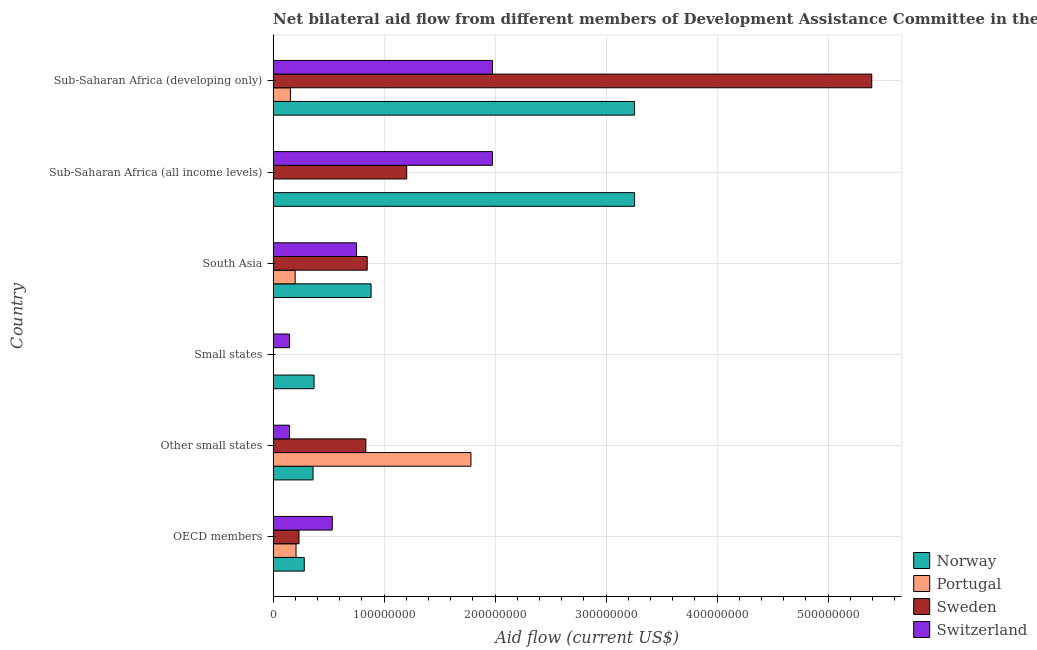How many groups of bars are there?
Your response must be concise. 6. Are the number of bars per tick equal to the number of legend labels?
Your answer should be very brief. Yes. How many bars are there on the 2nd tick from the bottom?
Offer a terse response. 4. What is the label of the 1st group of bars from the top?
Provide a succinct answer. Sub-Saharan Africa (developing only). What is the amount of aid given by portugal in South Asia?
Offer a terse response. 1.98e+07. Across all countries, what is the maximum amount of aid given by switzerland?
Make the answer very short. 1.98e+08. Across all countries, what is the minimum amount of aid given by portugal?
Make the answer very short. 4.00e+04. In which country was the amount of aid given by portugal maximum?
Offer a terse response. Other small states. In which country was the amount of aid given by norway minimum?
Your response must be concise. OECD members. What is the total amount of aid given by switzerland in the graph?
Provide a short and direct response. 5.53e+08. What is the difference between the amount of aid given by portugal in Small states and that in Sub-Saharan Africa (developing only)?
Your answer should be compact. -1.55e+07. What is the difference between the amount of aid given by portugal in South Asia and the amount of aid given by norway in OECD members?
Keep it short and to the point. -8.21e+06. What is the average amount of aid given by portugal per country?
Your answer should be very brief. 3.91e+07. What is the difference between the amount of aid given by norway and amount of aid given by switzerland in Sub-Saharan Africa (developing only)?
Offer a very short reply. 1.28e+08. In how many countries, is the amount of aid given by switzerland greater than 440000000 US$?
Keep it short and to the point. 0. What is the ratio of the amount of aid given by sweden in South Asia to that in Sub-Saharan Africa (all income levels)?
Your response must be concise. 0.7. Is the amount of aid given by sweden in OECD members less than that in Sub-Saharan Africa (all income levels)?
Give a very brief answer. Yes. Is the difference between the amount of aid given by sweden in Small states and South Asia greater than the difference between the amount of aid given by norway in Small states and South Asia?
Your answer should be compact. No. What is the difference between the highest and the second highest amount of aid given by sweden?
Ensure brevity in your answer.  4.19e+08. What is the difference between the highest and the lowest amount of aid given by sweden?
Ensure brevity in your answer.  5.39e+08. Is it the case that in every country, the sum of the amount of aid given by portugal and amount of aid given by switzerland is greater than the sum of amount of aid given by norway and amount of aid given by sweden?
Make the answer very short. No. How many bars are there?
Keep it short and to the point. 24. How many countries are there in the graph?
Provide a short and direct response. 6. What is the difference between two consecutive major ticks on the X-axis?
Offer a very short reply. 1.00e+08. Does the graph contain any zero values?
Ensure brevity in your answer.  No. How many legend labels are there?
Offer a terse response. 4. How are the legend labels stacked?
Make the answer very short. Vertical. What is the title of the graph?
Offer a very short reply. Net bilateral aid flow from different members of Development Assistance Committee in the year 1993. What is the label or title of the Y-axis?
Give a very brief answer. Country. What is the Aid flow (current US$) in Norway in OECD members?
Offer a terse response. 2.80e+07. What is the Aid flow (current US$) of Portugal in OECD members?
Keep it short and to the point. 2.06e+07. What is the Aid flow (current US$) of Sweden in OECD members?
Offer a very short reply. 2.33e+07. What is the Aid flow (current US$) in Switzerland in OECD members?
Offer a terse response. 5.33e+07. What is the Aid flow (current US$) in Norway in Other small states?
Provide a succinct answer. 3.60e+07. What is the Aid flow (current US$) of Portugal in Other small states?
Keep it short and to the point. 1.78e+08. What is the Aid flow (current US$) of Sweden in Other small states?
Ensure brevity in your answer.  8.35e+07. What is the Aid flow (current US$) of Switzerland in Other small states?
Your response must be concise. 1.48e+07. What is the Aid flow (current US$) in Norway in Small states?
Your answer should be very brief. 3.69e+07. What is the Aid flow (current US$) of Portugal in Small states?
Provide a succinct answer. 4.00e+04. What is the Aid flow (current US$) in Sweden in Small states?
Give a very brief answer. 5.00e+04. What is the Aid flow (current US$) in Switzerland in Small states?
Provide a succinct answer. 1.48e+07. What is the Aid flow (current US$) in Norway in South Asia?
Provide a short and direct response. 8.82e+07. What is the Aid flow (current US$) of Portugal in South Asia?
Your answer should be very brief. 1.98e+07. What is the Aid flow (current US$) in Sweden in South Asia?
Provide a succinct answer. 8.48e+07. What is the Aid flow (current US$) in Switzerland in South Asia?
Your response must be concise. 7.51e+07. What is the Aid flow (current US$) in Norway in Sub-Saharan Africa (all income levels)?
Offer a very short reply. 3.26e+08. What is the Aid flow (current US$) in Sweden in Sub-Saharan Africa (all income levels)?
Provide a succinct answer. 1.20e+08. What is the Aid flow (current US$) of Switzerland in Sub-Saharan Africa (all income levels)?
Provide a succinct answer. 1.98e+08. What is the Aid flow (current US$) in Norway in Sub-Saharan Africa (developing only)?
Provide a succinct answer. 3.26e+08. What is the Aid flow (current US$) of Portugal in Sub-Saharan Africa (developing only)?
Ensure brevity in your answer.  1.56e+07. What is the Aid flow (current US$) of Sweden in Sub-Saharan Africa (developing only)?
Offer a terse response. 5.39e+08. What is the Aid flow (current US$) of Switzerland in Sub-Saharan Africa (developing only)?
Your answer should be compact. 1.98e+08. Across all countries, what is the maximum Aid flow (current US$) of Norway?
Offer a very short reply. 3.26e+08. Across all countries, what is the maximum Aid flow (current US$) of Portugal?
Offer a very short reply. 1.78e+08. Across all countries, what is the maximum Aid flow (current US$) in Sweden?
Ensure brevity in your answer.  5.39e+08. Across all countries, what is the maximum Aid flow (current US$) in Switzerland?
Provide a succinct answer. 1.98e+08. Across all countries, what is the minimum Aid flow (current US$) of Norway?
Give a very brief answer. 2.80e+07. Across all countries, what is the minimum Aid flow (current US$) of Sweden?
Keep it short and to the point. 5.00e+04. Across all countries, what is the minimum Aid flow (current US$) in Switzerland?
Offer a terse response. 1.48e+07. What is the total Aid flow (current US$) of Norway in the graph?
Ensure brevity in your answer.  8.40e+08. What is the total Aid flow (current US$) in Portugal in the graph?
Make the answer very short. 2.35e+08. What is the total Aid flow (current US$) of Sweden in the graph?
Provide a short and direct response. 8.51e+08. What is the total Aid flow (current US$) in Switzerland in the graph?
Give a very brief answer. 5.53e+08. What is the difference between the Aid flow (current US$) of Norway in OECD members and that in Other small states?
Offer a terse response. -7.92e+06. What is the difference between the Aid flow (current US$) in Portugal in OECD members and that in Other small states?
Provide a succinct answer. -1.58e+08. What is the difference between the Aid flow (current US$) of Sweden in OECD members and that in Other small states?
Offer a very short reply. -6.02e+07. What is the difference between the Aid flow (current US$) in Switzerland in OECD members and that in Other small states?
Ensure brevity in your answer.  3.86e+07. What is the difference between the Aid flow (current US$) in Norway in OECD members and that in Small states?
Your answer should be compact. -8.82e+06. What is the difference between the Aid flow (current US$) in Portugal in OECD members and that in Small states?
Your response must be concise. 2.06e+07. What is the difference between the Aid flow (current US$) in Sweden in OECD members and that in Small states?
Offer a very short reply. 2.32e+07. What is the difference between the Aid flow (current US$) in Switzerland in OECD members and that in Small states?
Offer a very short reply. 3.85e+07. What is the difference between the Aid flow (current US$) of Norway in OECD members and that in South Asia?
Your answer should be compact. -6.02e+07. What is the difference between the Aid flow (current US$) of Portugal in OECD members and that in South Asia?
Provide a short and direct response. 8.00e+05. What is the difference between the Aid flow (current US$) in Sweden in OECD members and that in South Asia?
Keep it short and to the point. -6.15e+07. What is the difference between the Aid flow (current US$) in Switzerland in OECD members and that in South Asia?
Make the answer very short. -2.18e+07. What is the difference between the Aid flow (current US$) in Norway in OECD members and that in Sub-Saharan Africa (all income levels)?
Ensure brevity in your answer.  -2.98e+08. What is the difference between the Aid flow (current US$) of Portugal in OECD members and that in Sub-Saharan Africa (all income levels)?
Your answer should be compact. 2.04e+07. What is the difference between the Aid flow (current US$) in Sweden in OECD members and that in Sub-Saharan Africa (all income levels)?
Provide a short and direct response. -9.70e+07. What is the difference between the Aid flow (current US$) in Switzerland in OECD members and that in Sub-Saharan Africa (all income levels)?
Offer a terse response. -1.44e+08. What is the difference between the Aid flow (current US$) of Norway in OECD members and that in Sub-Saharan Africa (developing only)?
Provide a short and direct response. -2.98e+08. What is the difference between the Aid flow (current US$) of Portugal in OECD members and that in Sub-Saharan Africa (developing only)?
Provide a succinct answer. 5.09e+06. What is the difference between the Aid flow (current US$) in Sweden in OECD members and that in Sub-Saharan Africa (developing only)?
Your response must be concise. -5.16e+08. What is the difference between the Aid flow (current US$) in Switzerland in OECD members and that in Sub-Saharan Africa (developing only)?
Ensure brevity in your answer.  -1.44e+08. What is the difference between the Aid flow (current US$) in Norway in Other small states and that in Small states?
Your answer should be very brief. -9.00e+05. What is the difference between the Aid flow (current US$) of Portugal in Other small states and that in Small states?
Ensure brevity in your answer.  1.78e+08. What is the difference between the Aid flow (current US$) in Sweden in Other small states and that in Small states?
Give a very brief answer. 8.35e+07. What is the difference between the Aid flow (current US$) in Norway in Other small states and that in South Asia?
Give a very brief answer. -5.23e+07. What is the difference between the Aid flow (current US$) in Portugal in Other small states and that in South Asia?
Offer a very short reply. 1.58e+08. What is the difference between the Aid flow (current US$) in Sweden in Other small states and that in South Asia?
Provide a short and direct response. -1.22e+06. What is the difference between the Aid flow (current US$) in Switzerland in Other small states and that in South Asia?
Keep it short and to the point. -6.04e+07. What is the difference between the Aid flow (current US$) of Norway in Other small states and that in Sub-Saharan Africa (all income levels)?
Keep it short and to the point. -2.90e+08. What is the difference between the Aid flow (current US$) of Portugal in Other small states and that in Sub-Saharan Africa (all income levels)?
Offer a very short reply. 1.78e+08. What is the difference between the Aid flow (current US$) in Sweden in Other small states and that in Sub-Saharan Africa (all income levels)?
Ensure brevity in your answer.  -3.68e+07. What is the difference between the Aid flow (current US$) in Switzerland in Other small states and that in Sub-Saharan Africa (all income levels)?
Provide a succinct answer. -1.83e+08. What is the difference between the Aid flow (current US$) in Norway in Other small states and that in Sub-Saharan Africa (developing only)?
Offer a very short reply. -2.90e+08. What is the difference between the Aid flow (current US$) of Portugal in Other small states and that in Sub-Saharan Africa (developing only)?
Your answer should be very brief. 1.63e+08. What is the difference between the Aid flow (current US$) of Sweden in Other small states and that in Sub-Saharan Africa (developing only)?
Make the answer very short. -4.56e+08. What is the difference between the Aid flow (current US$) of Switzerland in Other small states and that in Sub-Saharan Africa (developing only)?
Provide a short and direct response. -1.83e+08. What is the difference between the Aid flow (current US$) in Norway in Small states and that in South Asia?
Provide a short and direct response. -5.14e+07. What is the difference between the Aid flow (current US$) in Portugal in Small states and that in South Asia?
Give a very brief answer. -1.98e+07. What is the difference between the Aid flow (current US$) in Sweden in Small states and that in South Asia?
Your answer should be very brief. -8.47e+07. What is the difference between the Aid flow (current US$) of Switzerland in Small states and that in South Asia?
Offer a terse response. -6.03e+07. What is the difference between the Aid flow (current US$) of Norway in Small states and that in Sub-Saharan Africa (all income levels)?
Keep it short and to the point. -2.89e+08. What is the difference between the Aid flow (current US$) in Sweden in Small states and that in Sub-Saharan Africa (all income levels)?
Ensure brevity in your answer.  -1.20e+08. What is the difference between the Aid flow (current US$) of Switzerland in Small states and that in Sub-Saharan Africa (all income levels)?
Offer a terse response. -1.83e+08. What is the difference between the Aid flow (current US$) of Norway in Small states and that in Sub-Saharan Africa (developing only)?
Make the answer very short. -2.89e+08. What is the difference between the Aid flow (current US$) in Portugal in Small states and that in Sub-Saharan Africa (developing only)?
Offer a terse response. -1.55e+07. What is the difference between the Aid flow (current US$) in Sweden in Small states and that in Sub-Saharan Africa (developing only)?
Offer a terse response. -5.39e+08. What is the difference between the Aid flow (current US$) of Switzerland in Small states and that in Sub-Saharan Africa (developing only)?
Make the answer very short. -1.83e+08. What is the difference between the Aid flow (current US$) in Norway in South Asia and that in Sub-Saharan Africa (all income levels)?
Your response must be concise. -2.37e+08. What is the difference between the Aid flow (current US$) of Portugal in South Asia and that in Sub-Saharan Africa (all income levels)?
Provide a succinct answer. 1.96e+07. What is the difference between the Aid flow (current US$) in Sweden in South Asia and that in Sub-Saharan Africa (all income levels)?
Your answer should be very brief. -3.56e+07. What is the difference between the Aid flow (current US$) of Switzerland in South Asia and that in Sub-Saharan Africa (all income levels)?
Your response must be concise. -1.22e+08. What is the difference between the Aid flow (current US$) in Norway in South Asia and that in Sub-Saharan Africa (developing only)?
Your answer should be very brief. -2.37e+08. What is the difference between the Aid flow (current US$) of Portugal in South Asia and that in Sub-Saharan Africa (developing only)?
Offer a terse response. 4.29e+06. What is the difference between the Aid flow (current US$) in Sweden in South Asia and that in Sub-Saharan Africa (developing only)?
Your answer should be very brief. -4.54e+08. What is the difference between the Aid flow (current US$) in Switzerland in South Asia and that in Sub-Saharan Africa (developing only)?
Your response must be concise. -1.22e+08. What is the difference between the Aid flow (current US$) of Portugal in Sub-Saharan Africa (all income levels) and that in Sub-Saharan Africa (developing only)?
Offer a terse response. -1.53e+07. What is the difference between the Aid flow (current US$) of Sweden in Sub-Saharan Africa (all income levels) and that in Sub-Saharan Africa (developing only)?
Offer a very short reply. -4.19e+08. What is the difference between the Aid flow (current US$) of Norway in OECD members and the Aid flow (current US$) of Portugal in Other small states?
Ensure brevity in your answer.  -1.50e+08. What is the difference between the Aid flow (current US$) in Norway in OECD members and the Aid flow (current US$) in Sweden in Other small states?
Keep it short and to the point. -5.55e+07. What is the difference between the Aid flow (current US$) of Norway in OECD members and the Aid flow (current US$) of Switzerland in Other small states?
Keep it short and to the point. 1.33e+07. What is the difference between the Aid flow (current US$) in Portugal in OECD members and the Aid flow (current US$) in Sweden in Other small states?
Offer a very short reply. -6.29e+07. What is the difference between the Aid flow (current US$) in Portugal in OECD members and the Aid flow (current US$) in Switzerland in Other small states?
Make the answer very short. 5.89e+06. What is the difference between the Aid flow (current US$) in Sweden in OECD members and the Aid flow (current US$) in Switzerland in Other small states?
Provide a short and direct response. 8.55e+06. What is the difference between the Aid flow (current US$) in Norway in OECD members and the Aid flow (current US$) in Portugal in Small states?
Ensure brevity in your answer.  2.80e+07. What is the difference between the Aid flow (current US$) of Norway in OECD members and the Aid flow (current US$) of Sweden in Small states?
Your answer should be compact. 2.80e+07. What is the difference between the Aid flow (current US$) in Norway in OECD members and the Aid flow (current US$) in Switzerland in Small states?
Provide a short and direct response. 1.32e+07. What is the difference between the Aid flow (current US$) in Portugal in OECD members and the Aid flow (current US$) in Sweden in Small states?
Offer a terse response. 2.06e+07. What is the difference between the Aid flow (current US$) of Portugal in OECD members and the Aid flow (current US$) of Switzerland in Small states?
Offer a terse response. 5.81e+06. What is the difference between the Aid flow (current US$) in Sweden in OECD members and the Aid flow (current US$) in Switzerland in Small states?
Provide a succinct answer. 8.47e+06. What is the difference between the Aid flow (current US$) of Norway in OECD members and the Aid flow (current US$) of Portugal in South Asia?
Make the answer very short. 8.21e+06. What is the difference between the Aid flow (current US$) of Norway in OECD members and the Aid flow (current US$) of Sweden in South Asia?
Your response must be concise. -5.67e+07. What is the difference between the Aid flow (current US$) in Norway in OECD members and the Aid flow (current US$) in Switzerland in South Asia?
Provide a short and direct response. -4.71e+07. What is the difference between the Aid flow (current US$) of Portugal in OECD members and the Aid flow (current US$) of Sweden in South Asia?
Provide a short and direct response. -6.41e+07. What is the difference between the Aid flow (current US$) of Portugal in OECD members and the Aid flow (current US$) of Switzerland in South Asia?
Make the answer very short. -5.45e+07. What is the difference between the Aid flow (current US$) in Sweden in OECD members and the Aid flow (current US$) in Switzerland in South Asia?
Your answer should be very brief. -5.18e+07. What is the difference between the Aid flow (current US$) in Norway in OECD members and the Aid flow (current US$) in Portugal in Sub-Saharan Africa (all income levels)?
Your answer should be compact. 2.78e+07. What is the difference between the Aid flow (current US$) in Norway in OECD members and the Aid flow (current US$) in Sweden in Sub-Saharan Africa (all income levels)?
Ensure brevity in your answer.  -9.23e+07. What is the difference between the Aid flow (current US$) in Norway in OECD members and the Aid flow (current US$) in Switzerland in Sub-Saharan Africa (all income levels)?
Keep it short and to the point. -1.70e+08. What is the difference between the Aid flow (current US$) in Portugal in OECD members and the Aid flow (current US$) in Sweden in Sub-Saharan Africa (all income levels)?
Provide a short and direct response. -9.97e+07. What is the difference between the Aid flow (current US$) of Portugal in OECD members and the Aid flow (current US$) of Switzerland in Sub-Saharan Africa (all income levels)?
Offer a very short reply. -1.77e+08. What is the difference between the Aid flow (current US$) of Sweden in OECD members and the Aid flow (current US$) of Switzerland in Sub-Saharan Africa (all income levels)?
Ensure brevity in your answer.  -1.74e+08. What is the difference between the Aid flow (current US$) in Norway in OECD members and the Aid flow (current US$) in Portugal in Sub-Saharan Africa (developing only)?
Give a very brief answer. 1.25e+07. What is the difference between the Aid flow (current US$) of Norway in OECD members and the Aid flow (current US$) of Sweden in Sub-Saharan Africa (developing only)?
Provide a succinct answer. -5.11e+08. What is the difference between the Aid flow (current US$) in Norway in OECD members and the Aid flow (current US$) in Switzerland in Sub-Saharan Africa (developing only)?
Offer a terse response. -1.70e+08. What is the difference between the Aid flow (current US$) in Portugal in OECD members and the Aid flow (current US$) in Sweden in Sub-Saharan Africa (developing only)?
Provide a short and direct response. -5.19e+08. What is the difference between the Aid flow (current US$) in Portugal in OECD members and the Aid flow (current US$) in Switzerland in Sub-Saharan Africa (developing only)?
Offer a terse response. -1.77e+08. What is the difference between the Aid flow (current US$) in Sweden in OECD members and the Aid flow (current US$) in Switzerland in Sub-Saharan Africa (developing only)?
Give a very brief answer. -1.74e+08. What is the difference between the Aid flow (current US$) in Norway in Other small states and the Aid flow (current US$) in Portugal in Small states?
Ensure brevity in your answer.  3.59e+07. What is the difference between the Aid flow (current US$) in Norway in Other small states and the Aid flow (current US$) in Sweden in Small states?
Keep it short and to the point. 3.59e+07. What is the difference between the Aid flow (current US$) of Norway in Other small states and the Aid flow (current US$) of Switzerland in Small states?
Offer a terse response. 2.11e+07. What is the difference between the Aid flow (current US$) in Portugal in Other small states and the Aid flow (current US$) in Sweden in Small states?
Keep it short and to the point. 1.78e+08. What is the difference between the Aid flow (current US$) in Portugal in Other small states and the Aid flow (current US$) in Switzerland in Small states?
Ensure brevity in your answer.  1.63e+08. What is the difference between the Aid flow (current US$) of Sweden in Other small states and the Aid flow (current US$) of Switzerland in Small states?
Offer a very short reply. 6.87e+07. What is the difference between the Aid flow (current US$) in Norway in Other small states and the Aid flow (current US$) in Portugal in South Asia?
Provide a short and direct response. 1.61e+07. What is the difference between the Aid flow (current US$) of Norway in Other small states and the Aid flow (current US$) of Sweden in South Asia?
Give a very brief answer. -4.88e+07. What is the difference between the Aid flow (current US$) in Norway in Other small states and the Aid flow (current US$) in Switzerland in South Asia?
Give a very brief answer. -3.92e+07. What is the difference between the Aid flow (current US$) in Portugal in Other small states and the Aid flow (current US$) in Sweden in South Asia?
Provide a short and direct response. 9.34e+07. What is the difference between the Aid flow (current US$) in Portugal in Other small states and the Aid flow (current US$) in Switzerland in South Asia?
Ensure brevity in your answer.  1.03e+08. What is the difference between the Aid flow (current US$) of Sweden in Other small states and the Aid flow (current US$) of Switzerland in South Asia?
Provide a short and direct response. 8.40e+06. What is the difference between the Aid flow (current US$) in Norway in Other small states and the Aid flow (current US$) in Portugal in Sub-Saharan Africa (all income levels)?
Your response must be concise. 3.57e+07. What is the difference between the Aid flow (current US$) of Norway in Other small states and the Aid flow (current US$) of Sweden in Sub-Saharan Africa (all income levels)?
Offer a very short reply. -8.44e+07. What is the difference between the Aid flow (current US$) in Norway in Other small states and the Aid flow (current US$) in Switzerland in Sub-Saharan Africa (all income levels)?
Your response must be concise. -1.62e+08. What is the difference between the Aid flow (current US$) in Portugal in Other small states and the Aid flow (current US$) in Sweden in Sub-Saharan Africa (all income levels)?
Make the answer very short. 5.79e+07. What is the difference between the Aid flow (current US$) of Portugal in Other small states and the Aid flow (current US$) of Switzerland in Sub-Saharan Africa (all income levels)?
Give a very brief answer. -1.94e+07. What is the difference between the Aid flow (current US$) in Sweden in Other small states and the Aid flow (current US$) in Switzerland in Sub-Saharan Africa (all income levels)?
Your answer should be compact. -1.14e+08. What is the difference between the Aid flow (current US$) in Norway in Other small states and the Aid flow (current US$) in Portugal in Sub-Saharan Africa (developing only)?
Provide a short and direct response. 2.04e+07. What is the difference between the Aid flow (current US$) in Norway in Other small states and the Aid flow (current US$) in Sweden in Sub-Saharan Africa (developing only)?
Your answer should be compact. -5.03e+08. What is the difference between the Aid flow (current US$) in Norway in Other small states and the Aid flow (current US$) in Switzerland in Sub-Saharan Africa (developing only)?
Make the answer very short. -1.62e+08. What is the difference between the Aid flow (current US$) of Portugal in Other small states and the Aid flow (current US$) of Sweden in Sub-Saharan Africa (developing only)?
Keep it short and to the point. -3.61e+08. What is the difference between the Aid flow (current US$) in Portugal in Other small states and the Aid flow (current US$) in Switzerland in Sub-Saharan Africa (developing only)?
Keep it short and to the point. -1.94e+07. What is the difference between the Aid flow (current US$) in Sweden in Other small states and the Aid flow (current US$) in Switzerland in Sub-Saharan Africa (developing only)?
Your answer should be compact. -1.14e+08. What is the difference between the Aid flow (current US$) of Norway in Small states and the Aid flow (current US$) of Portugal in South Asia?
Provide a succinct answer. 1.70e+07. What is the difference between the Aid flow (current US$) of Norway in Small states and the Aid flow (current US$) of Sweden in South Asia?
Provide a short and direct response. -4.79e+07. What is the difference between the Aid flow (current US$) in Norway in Small states and the Aid flow (current US$) in Switzerland in South Asia?
Your answer should be very brief. -3.83e+07. What is the difference between the Aid flow (current US$) in Portugal in Small states and the Aid flow (current US$) in Sweden in South Asia?
Keep it short and to the point. -8.47e+07. What is the difference between the Aid flow (current US$) in Portugal in Small states and the Aid flow (current US$) in Switzerland in South Asia?
Ensure brevity in your answer.  -7.51e+07. What is the difference between the Aid flow (current US$) of Sweden in Small states and the Aid flow (current US$) of Switzerland in South Asia?
Ensure brevity in your answer.  -7.51e+07. What is the difference between the Aid flow (current US$) of Norway in Small states and the Aid flow (current US$) of Portugal in Sub-Saharan Africa (all income levels)?
Give a very brief answer. 3.66e+07. What is the difference between the Aid flow (current US$) of Norway in Small states and the Aid flow (current US$) of Sweden in Sub-Saharan Africa (all income levels)?
Ensure brevity in your answer.  -8.35e+07. What is the difference between the Aid flow (current US$) in Norway in Small states and the Aid flow (current US$) in Switzerland in Sub-Saharan Africa (all income levels)?
Your answer should be compact. -1.61e+08. What is the difference between the Aid flow (current US$) in Portugal in Small states and the Aid flow (current US$) in Sweden in Sub-Saharan Africa (all income levels)?
Ensure brevity in your answer.  -1.20e+08. What is the difference between the Aid flow (current US$) of Portugal in Small states and the Aid flow (current US$) of Switzerland in Sub-Saharan Africa (all income levels)?
Offer a very short reply. -1.98e+08. What is the difference between the Aid flow (current US$) in Sweden in Small states and the Aid flow (current US$) in Switzerland in Sub-Saharan Africa (all income levels)?
Offer a very short reply. -1.98e+08. What is the difference between the Aid flow (current US$) of Norway in Small states and the Aid flow (current US$) of Portugal in Sub-Saharan Africa (developing only)?
Your answer should be very brief. 2.13e+07. What is the difference between the Aid flow (current US$) in Norway in Small states and the Aid flow (current US$) in Sweden in Sub-Saharan Africa (developing only)?
Your answer should be compact. -5.02e+08. What is the difference between the Aid flow (current US$) of Norway in Small states and the Aid flow (current US$) of Switzerland in Sub-Saharan Africa (developing only)?
Provide a short and direct response. -1.61e+08. What is the difference between the Aid flow (current US$) in Portugal in Small states and the Aid flow (current US$) in Sweden in Sub-Saharan Africa (developing only)?
Provide a short and direct response. -5.39e+08. What is the difference between the Aid flow (current US$) of Portugal in Small states and the Aid flow (current US$) of Switzerland in Sub-Saharan Africa (developing only)?
Ensure brevity in your answer.  -1.98e+08. What is the difference between the Aid flow (current US$) of Sweden in Small states and the Aid flow (current US$) of Switzerland in Sub-Saharan Africa (developing only)?
Provide a succinct answer. -1.98e+08. What is the difference between the Aid flow (current US$) in Norway in South Asia and the Aid flow (current US$) in Portugal in Sub-Saharan Africa (all income levels)?
Your response must be concise. 8.80e+07. What is the difference between the Aid flow (current US$) of Norway in South Asia and the Aid flow (current US$) of Sweden in Sub-Saharan Africa (all income levels)?
Your answer should be very brief. -3.21e+07. What is the difference between the Aid flow (current US$) in Norway in South Asia and the Aid flow (current US$) in Switzerland in Sub-Saharan Africa (all income levels)?
Offer a terse response. -1.09e+08. What is the difference between the Aid flow (current US$) in Portugal in South Asia and the Aid flow (current US$) in Sweden in Sub-Saharan Africa (all income levels)?
Ensure brevity in your answer.  -1.01e+08. What is the difference between the Aid flow (current US$) in Portugal in South Asia and the Aid flow (current US$) in Switzerland in Sub-Saharan Africa (all income levels)?
Your answer should be compact. -1.78e+08. What is the difference between the Aid flow (current US$) of Sweden in South Asia and the Aid flow (current US$) of Switzerland in Sub-Saharan Africa (all income levels)?
Keep it short and to the point. -1.13e+08. What is the difference between the Aid flow (current US$) in Norway in South Asia and the Aid flow (current US$) in Portugal in Sub-Saharan Africa (developing only)?
Ensure brevity in your answer.  7.27e+07. What is the difference between the Aid flow (current US$) in Norway in South Asia and the Aid flow (current US$) in Sweden in Sub-Saharan Africa (developing only)?
Keep it short and to the point. -4.51e+08. What is the difference between the Aid flow (current US$) of Norway in South Asia and the Aid flow (current US$) of Switzerland in Sub-Saharan Africa (developing only)?
Your response must be concise. -1.09e+08. What is the difference between the Aid flow (current US$) of Portugal in South Asia and the Aid flow (current US$) of Sweden in Sub-Saharan Africa (developing only)?
Provide a succinct answer. -5.19e+08. What is the difference between the Aid flow (current US$) in Portugal in South Asia and the Aid flow (current US$) in Switzerland in Sub-Saharan Africa (developing only)?
Your answer should be compact. -1.78e+08. What is the difference between the Aid flow (current US$) of Sweden in South Asia and the Aid flow (current US$) of Switzerland in Sub-Saharan Africa (developing only)?
Your answer should be compact. -1.13e+08. What is the difference between the Aid flow (current US$) of Norway in Sub-Saharan Africa (all income levels) and the Aid flow (current US$) of Portugal in Sub-Saharan Africa (developing only)?
Provide a short and direct response. 3.10e+08. What is the difference between the Aid flow (current US$) of Norway in Sub-Saharan Africa (all income levels) and the Aid flow (current US$) of Sweden in Sub-Saharan Africa (developing only)?
Keep it short and to the point. -2.14e+08. What is the difference between the Aid flow (current US$) of Norway in Sub-Saharan Africa (all income levels) and the Aid flow (current US$) of Switzerland in Sub-Saharan Africa (developing only)?
Make the answer very short. 1.28e+08. What is the difference between the Aid flow (current US$) of Portugal in Sub-Saharan Africa (all income levels) and the Aid flow (current US$) of Sweden in Sub-Saharan Africa (developing only)?
Offer a terse response. -5.39e+08. What is the difference between the Aid flow (current US$) of Portugal in Sub-Saharan Africa (all income levels) and the Aid flow (current US$) of Switzerland in Sub-Saharan Africa (developing only)?
Give a very brief answer. -1.97e+08. What is the difference between the Aid flow (current US$) in Sweden in Sub-Saharan Africa (all income levels) and the Aid flow (current US$) in Switzerland in Sub-Saharan Africa (developing only)?
Keep it short and to the point. -7.72e+07. What is the average Aid flow (current US$) of Norway per country?
Make the answer very short. 1.40e+08. What is the average Aid flow (current US$) of Portugal per country?
Make the answer very short. 3.91e+07. What is the average Aid flow (current US$) in Sweden per country?
Your answer should be very brief. 1.42e+08. What is the average Aid flow (current US$) in Switzerland per country?
Your answer should be very brief. 9.22e+07. What is the difference between the Aid flow (current US$) in Norway and Aid flow (current US$) in Portugal in OECD members?
Your answer should be compact. 7.41e+06. What is the difference between the Aid flow (current US$) of Norway and Aid flow (current US$) of Sweden in OECD members?
Your response must be concise. 4.75e+06. What is the difference between the Aid flow (current US$) in Norway and Aid flow (current US$) in Switzerland in OECD members?
Offer a terse response. -2.52e+07. What is the difference between the Aid flow (current US$) in Portugal and Aid flow (current US$) in Sweden in OECD members?
Offer a very short reply. -2.66e+06. What is the difference between the Aid flow (current US$) in Portugal and Aid flow (current US$) in Switzerland in OECD members?
Offer a very short reply. -3.27e+07. What is the difference between the Aid flow (current US$) in Sweden and Aid flow (current US$) in Switzerland in OECD members?
Provide a succinct answer. -3.00e+07. What is the difference between the Aid flow (current US$) of Norway and Aid flow (current US$) of Portugal in Other small states?
Your answer should be very brief. -1.42e+08. What is the difference between the Aid flow (current US$) of Norway and Aid flow (current US$) of Sweden in Other small states?
Provide a short and direct response. -4.76e+07. What is the difference between the Aid flow (current US$) of Norway and Aid flow (current US$) of Switzerland in Other small states?
Make the answer very short. 2.12e+07. What is the difference between the Aid flow (current US$) in Portugal and Aid flow (current US$) in Sweden in Other small states?
Provide a short and direct response. 9.47e+07. What is the difference between the Aid flow (current US$) in Portugal and Aid flow (current US$) in Switzerland in Other small states?
Your response must be concise. 1.63e+08. What is the difference between the Aid flow (current US$) of Sweden and Aid flow (current US$) of Switzerland in Other small states?
Offer a very short reply. 6.88e+07. What is the difference between the Aid flow (current US$) of Norway and Aid flow (current US$) of Portugal in Small states?
Your answer should be compact. 3.68e+07. What is the difference between the Aid flow (current US$) in Norway and Aid flow (current US$) in Sweden in Small states?
Keep it short and to the point. 3.68e+07. What is the difference between the Aid flow (current US$) in Norway and Aid flow (current US$) in Switzerland in Small states?
Offer a very short reply. 2.20e+07. What is the difference between the Aid flow (current US$) in Portugal and Aid flow (current US$) in Sweden in Small states?
Keep it short and to the point. -10000. What is the difference between the Aid flow (current US$) in Portugal and Aid flow (current US$) in Switzerland in Small states?
Offer a terse response. -1.48e+07. What is the difference between the Aid flow (current US$) of Sweden and Aid flow (current US$) of Switzerland in Small states?
Offer a very short reply. -1.48e+07. What is the difference between the Aid flow (current US$) of Norway and Aid flow (current US$) of Portugal in South Asia?
Provide a succinct answer. 6.84e+07. What is the difference between the Aid flow (current US$) of Norway and Aid flow (current US$) of Sweden in South Asia?
Make the answer very short. 3.48e+06. What is the difference between the Aid flow (current US$) of Norway and Aid flow (current US$) of Switzerland in South Asia?
Your answer should be very brief. 1.31e+07. What is the difference between the Aid flow (current US$) of Portugal and Aid flow (current US$) of Sweden in South Asia?
Keep it short and to the point. -6.49e+07. What is the difference between the Aid flow (current US$) in Portugal and Aid flow (current US$) in Switzerland in South Asia?
Offer a terse response. -5.53e+07. What is the difference between the Aid flow (current US$) in Sweden and Aid flow (current US$) in Switzerland in South Asia?
Offer a very short reply. 9.62e+06. What is the difference between the Aid flow (current US$) in Norway and Aid flow (current US$) in Portugal in Sub-Saharan Africa (all income levels)?
Provide a succinct answer. 3.25e+08. What is the difference between the Aid flow (current US$) in Norway and Aid flow (current US$) in Sweden in Sub-Saharan Africa (all income levels)?
Provide a short and direct response. 2.05e+08. What is the difference between the Aid flow (current US$) of Norway and Aid flow (current US$) of Switzerland in Sub-Saharan Africa (all income levels)?
Ensure brevity in your answer.  1.28e+08. What is the difference between the Aid flow (current US$) of Portugal and Aid flow (current US$) of Sweden in Sub-Saharan Africa (all income levels)?
Offer a very short reply. -1.20e+08. What is the difference between the Aid flow (current US$) in Portugal and Aid flow (current US$) in Switzerland in Sub-Saharan Africa (all income levels)?
Provide a succinct answer. -1.97e+08. What is the difference between the Aid flow (current US$) of Sweden and Aid flow (current US$) of Switzerland in Sub-Saharan Africa (all income levels)?
Provide a succinct answer. -7.72e+07. What is the difference between the Aid flow (current US$) of Norway and Aid flow (current US$) of Portugal in Sub-Saharan Africa (developing only)?
Offer a very short reply. 3.10e+08. What is the difference between the Aid flow (current US$) in Norway and Aid flow (current US$) in Sweden in Sub-Saharan Africa (developing only)?
Your answer should be compact. -2.14e+08. What is the difference between the Aid flow (current US$) in Norway and Aid flow (current US$) in Switzerland in Sub-Saharan Africa (developing only)?
Offer a very short reply. 1.28e+08. What is the difference between the Aid flow (current US$) of Portugal and Aid flow (current US$) of Sweden in Sub-Saharan Africa (developing only)?
Your answer should be very brief. -5.24e+08. What is the difference between the Aid flow (current US$) in Portugal and Aid flow (current US$) in Switzerland in Sub-Saharan Africa (developing only)?
Offer a very short reply. -1.82e+08. What is the difference between the Aid flow (current US$) in Sweden and Aid flow (current US$) in Switzerland in Sub-Saharan Africa (developing only)?
Give a very brief answer. 3.42e+08. What is the ratio of the Aid flow (current US$) in Norway in OECD members to that in Other small states?
Your answer should be very brief. 0.78. What is the ratio of the Aid flow (current US$) in Portugal in OECD members to that in Other small states?
Keep it short and to the point. 0.12. What is the ratio of the Aid flow (current US$) in Sweden in OECD members to that in Other small states?
Ensure brevity in your answer.  0.28. What is the ratio of the Aid flow (current US$) of Switzerland in OECD members to that in Other small states?
Offer a very short reply. 3.61. What is the ratio of the Aid flow (current US$) of Norway in OECD members to that in Small states?
Provide a succinct answer. 0.76. What is the ratio of the Aid flow (current US$) in Portugal in OECD members to that in Small states?
Offer a terse response. 516. What is the ratio of the Aid flow (current US$) in Sweden in OECD members to that in Small states?
Give a very brief answer. 466. What is the ratio of the Aid flow (current US$) in Switzerland in OECD members to that in Small states?
Provide a succinct answer. 3.59. What is the ratio of the Aid flow (current US$) of Norway in OECD members to that in South Asia?
Provide a succinct answer. 0.32. What is the ratio of the Aid flow (current US$) in Portugal in OECD members to that in South Asia?
Your answer should be very brief. 1.04. What is the ratio of the Aid flow (current US$) in Sweden in OECD members to that in South Asia?
Make the answer very short. 0.27. What is the ratio of the Aid flow (current US$) of Switzerland in OECD members to that in South Asia?
Your answer should be compact. 0.71. What is the ratio of the Aid flow (current US$) of Norway in OECD members to that in Sub-Saharan Africa (all income levels)?
Offer a very short reply. 0.09. What is the ratio of the Aid flow (current US$) in Portugal in OECD members to that in Sub-Saharan Africa (all income levels)?
Give a very brief answer. 82.56. What is the ratio of the Aid flow (current US$) in Sweden in OECD members to that in Sub-Saharan Africa (all income levels)?
Ensure brevity in your answer.  0.19. What is the ratio of the Aid flow (current US$) of Switzerland in OECD members to that in Sub-Saharan Africa (all income levels)?
Ensure brevity in your answer.  0.27. What is the ratio of the Aid flow (current US$) of Norway in OECD members to that in Sub-Saharan Africa (developing only)?
Your answer should be compact. 0.09. What is the ratio of the Aid flow (current US$) in Portugal in OECD members to that in Sub-Saharan Africa (developing only)?
Your answer should be compact. 1.33. What is the ratio of the Aid flow (current US$) of Sweden in OECD members to that in Sub-Saharan Africa (developing only)?
Give a very brief answer. 0.04. What is the ratio of the Aid flow (current US$) of Switzerland in OECD members to that in Sub-Saharan Africa (developing only)?
Your answer should be compact. 0.27. What is the ratio of the Aid flow (current US$) in Norway in Other small states to that in Small states?
Ensure brevity in your answer.  0.98. What is the ratio of the Aid flow (current US$) of Portugal in Other small states to that in Small states?
Offer a terse response. 4455.25. What is the ratio of the Aid flow (current US$) in Sweden in Other small states to that in Small states?
Offer a terse response. 1670.8. What is the ratio of the Aid flow (current US$) in Switzerland in Other small states to that in Small states?
Keep it short and to the point. 0.99. What is the ratio of the Aid flow (current US$) in Norway in Other small states to that in South Asia?
Offer a terse response. 0.41. What is the ratio of the Aid flow (current US$) in Portugal in Other small states to that in South Asia?
Provide a succinct answer. 8.98. What is the ratio of the Aid flow (current US$) in Sweden in Other small states to that in South Asia?
Offer a terse response. 0.99. What is the ratio of the Aid flow (current US$) in Switzerland in Other small states to that in South Asia?
Offer a terse response. 0.2. What is the ratio of the Aid flow (current US$) of Norway in Other small states to that in Sub-Saharan Africa (all income levels)?
Your answer should be compact. 0.11. What is the ratio of the Aid flow (current US$) in Portugal in Other small states to that in Sub-Saharan Africa (all income levels)?
Your response must be concise. 712.84. What is the ratio of the Aid flow (current US$) in Sweden in Other small states to that in Sub-Saharan Africa (all income levels)?
Provide a succinct answer. 0.69. What is the ratio of the Aid flow (current US$) of Switzerland in Other small states to that in Sub-Saharan Africa (all income levels)?
Offer a very short reply. 0.07. What is the ratio of the Aid flow (current US$) of Norway in Other small states to that in Sub-Saharan Africa (developing only)?
Offer a very short reply. 0.11. What is the ratio of the Aid flow (current US$) in Portugal in Other small states to that in Sub-Saharan Africa (developing only)?
Provide a succinct answer. 11.46. What is the ratio of the Aid flow (current US$) in Sweden in Other small states to that in Sub-Saharan Africa (developing only)?
Your response must be concise. 0.15. What is the ratio of the Aid flow (current US$) in Switzerland in Other small states to that in Sub-Saharan Africa (developing only)?
Offer a terse response. 0.07. What is the ratio of the Aid flow (current US$) in Norway in Small states to that in South Asia?
Your answer should be very brief. 0.42. What is the ratio of the Aid flow (current US$) of Portugal in Small states to that in South Asia?
Offer a terse response. 0. What is the ratio of the Aid flow (current US$) of Sweden in Small states to that in South Asia?
Give a very brief answer. 0. What is the ratio of the Aid flow (current US$) of Switzerland in Small states to that in South Asia?
Ensure brevity in your answer.  0.2. What is the ratio of the Aid flow (current US$) in Norway in Small states to that in Sub-Saharan Africa (all income levels)?
Give a very brief answer. 0.11. What is the ratio of the Aid flow (current US$) in Portugal in Small states to that in Sub-Saharan Africa (all income levels)?
Give a very brief answer. 0.16. What is the ratio of the Aid flow (current US$) in Sweden in Small states to that in Sub-Saharan Africa (all income levels)?
Give a very brief answer. 0. What is the ratio of the Aid flow (current US$) of Switzerland in Small states to that in Sub-Saharan Africa (all income levels)?
Give a very brief answer. 0.08. What is the ratio of the Aid flow (current US$) in Norway in Small states to that in Sub-Saharan Africa (developing only)?
Your response must be concise. 0.11. What is the ratio of the Aid flow (current US$) in Portugal in Small states to that in Sub-Saharan Africa (developing only)?
Give a very brief answer. 0. What is the ratio of the Aid flow (current US$) of Sweden in Small states to that in Sub-Saharan Africa (developing only)?
Make the answer very short. 0. What is the ratio of the Aid flow (current US$) in Switzerland in Small states to that in Sub-Saharan Africa (developing only)?
Offer a very short reply. 0.08. What is the ratio of the Aid flow (current US$) of Norway in South Asia to that in Sub-Saharan Africa (all income levels)?
Ensure brevity in your answer.  0.27. What is the ratio of the Aid flow (current US$) in Portugal in South Asia to that in Sub-Saharan Africa (all income levels)?
Your answer should be very brief. 79.36. What is the ratio of the Aid flow (current US$) of Sweden in South Asia to that in Sub-Saharan Africa (all income levels)?
Offer a terse response. 0.7. What is the ratio of the Aid flow (current US$) of Switzerland in South Asia to that in Sub-Saharan Africa (all income levels)?
Your answer should be very brief. 0.38. What is the ratio of the Aid flow (current US$) in Norway in South Asia to that in Sub-Saharan Africa (developing only)?
Ensure brevity in your answer.  0.27. What is the ratio of the Aid flow (current US$) in Portugal in South Asia to that in Sub-Saharan Africa (developing only)?
Your answer should be very brief. 1.28. What is the ratio of the Aid flow (current US$) in Sweden in South Asia to that in Sub-Saharan Africa (developing only)?
Provide a short and direct response. 0.16. What is the ratio of the Aid flow (current US$) of Switzerland in South Asia to that in Sub-Saharan Africa (developing only)?
Provide a succinct answer. 0.38. What is the ratio of the Aid flow (current US$) in Norway in Sub-Saharan Africa (all income levels) to that in Sub-Saharan Africa (developing only)?
Provide a short and direct response. 1. What is the ratio of the Aid flow (current US$) in Portugal in Sub-Saharan Africa (all income levels) to that in Sub-Saharan Africa (developing only)?
Your answer should be compact. 0.02. What is the ratio of the Aid flow (current US$) in Sweden in Sub-Saharan Africa (all income levels) to that in Sub-Saharan Africa (developing only)?
Your answer should be compact. 0.22. What is the ratio of the Aid flow (current US$) in Switzerland in Sub-Saharan Africa (all income levels) to that in Sub-Saharan Africa (developing only)?
Offer a very short reply. 1. What is the difference between the highest and the second highest Aid flow (current US$) in Portugal?
Your answer should be very brief. 1.58e+08. What is the difference between the highest and the second highest Aid flow (current US$) of Sweden?
Ensure brevity in your answer.  4.19e+08. What is the difference between the highest and the lowest Aid flow (current US$) of Norway?
Provide a short and direct response. 2.98e+08. What is the difference between the highest and the lowest Aid flow (current US$) in Portugal?
Provide a short and direct response. 1.78e+08. What is the difference between the highest and the lowest Aid flow (current US$) in Sweden?
Your response must be concise. 5.39e+08. What is the difference between the highest and the lowest Aid flow (current US$) in Switzerland?
Provide a short and direct response. 1.83e+08. 